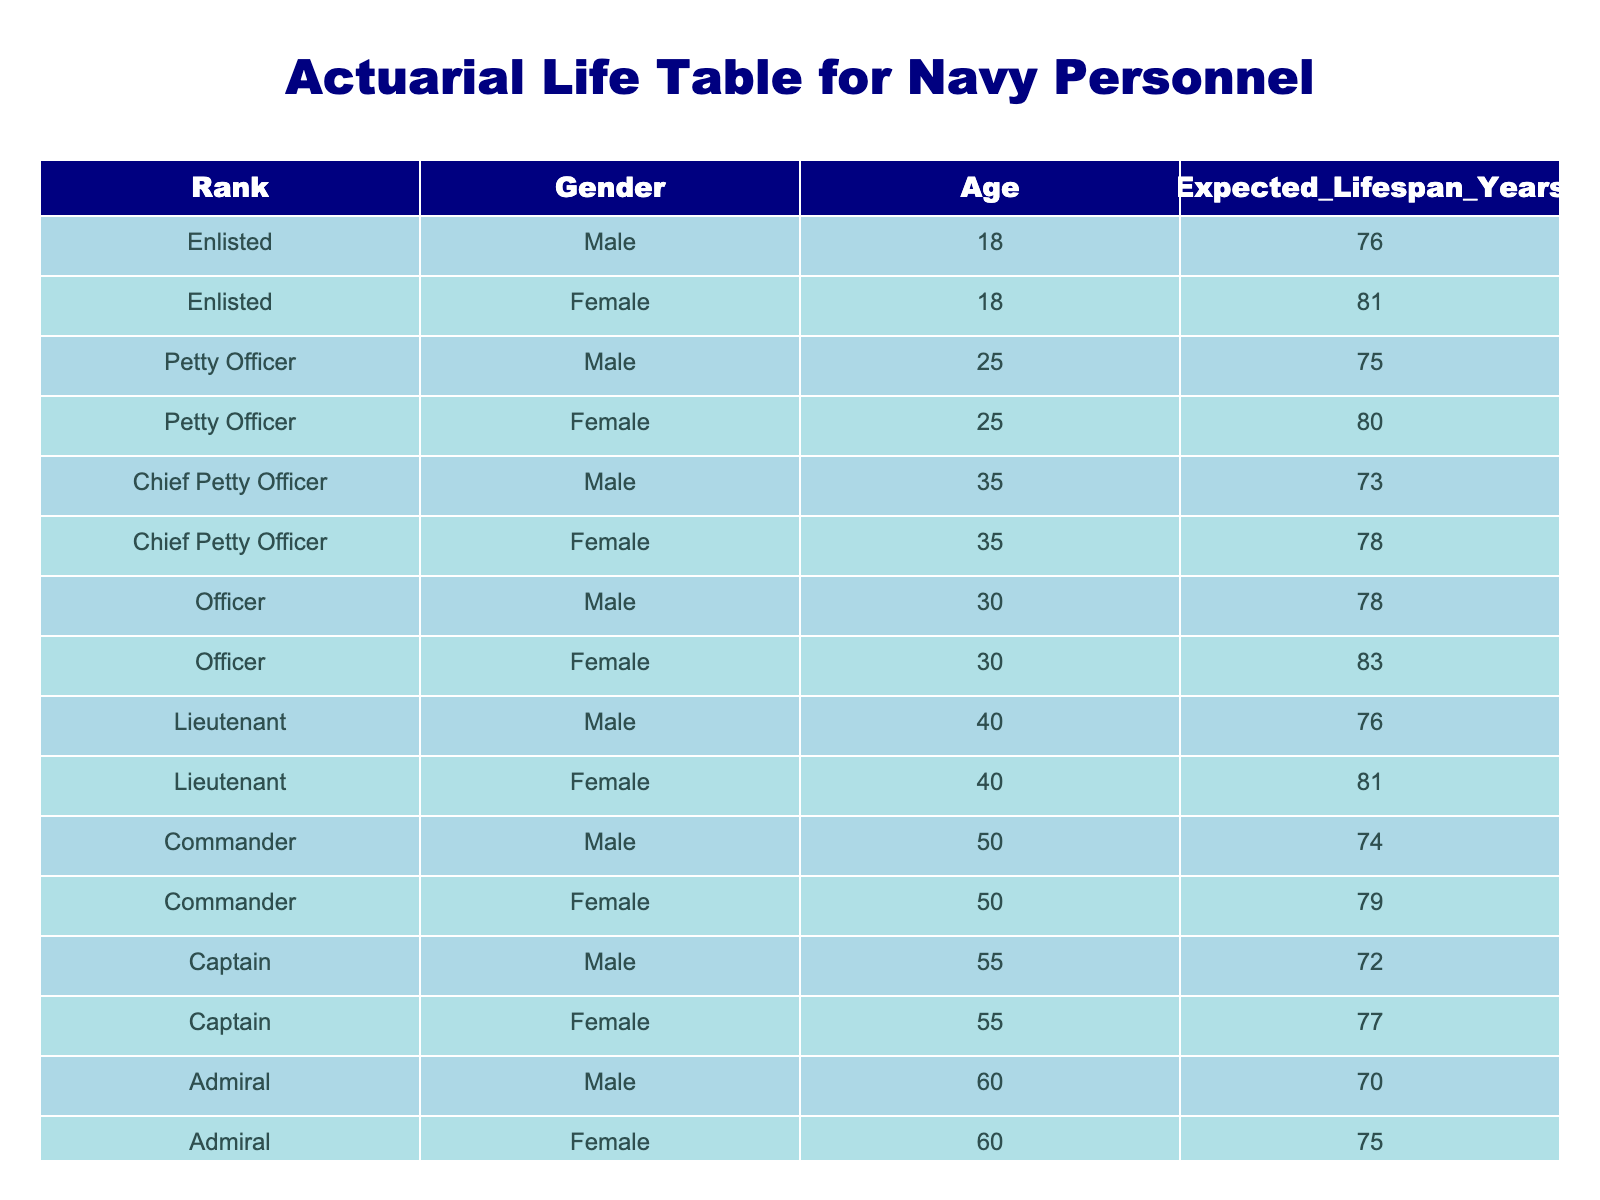What is the expected lifespan of a Male Chief Petty Officer? The table shows that the expected lifespan of a Male Chief Petty Officer is 73 years, as directly referenced from the corresponding row for this rank and gender.
Answer: 73 What is the expected lifespan of a Female Officer? The expected lifespan of a Female Officer is 83 years, found in the table where this specific rank and gender is listed.
Answer: 83 Which gender has a longer projected lifespan at the rank of Admiral? At the rank of Admiral, the table indicates that Female Admirals have an expected lifespan of 75 years while Male Admirals have 70 years. Therefore, Females have a longer lifespan.
Answer: Yes What is the difference between the expected lifespans of Enlisted Males and Petty Officer Females? The expected lifespan of Enlisted Males is 76 years, and for Petty Officer Females, it is 80 years. To find the difference, we subtract: 80 - 76 = 4 years.
Answer: 4 years What is the average expected lifespan for Petty Officers? The expected lifespans for Petty Officers from the table are 75 years for Males and 80 years for Females. To calculate the average: (75 + 80) / 2 = 77.5 years.
Answer: 77.5 What is the expected lifespan of a 40-year-old Male Lieutenant? The table lists the expected lifespan of a Male Lieutenant at age 40 as 76 years. This information can be directly located in the relevant row.
Answer: 76 Is it true that Female Captains have a shorter expected lifespan than Male Captains? According to the table, Female Captains have an expected lifespan of 77 years, while Male Captains have 72 years. This means Females have a longer lifespan and the statement is false.
Answer: No What is the expected lifespan for the youngest enlisted personnel? The table indicates that the expected lifespan of an 18-year-old Enlisted Male is 76 years and for an Enlisted Female it is 81 years. The youngest enlisted personnel being Male has an expected lifespan of 76 years.
Answer: 76 